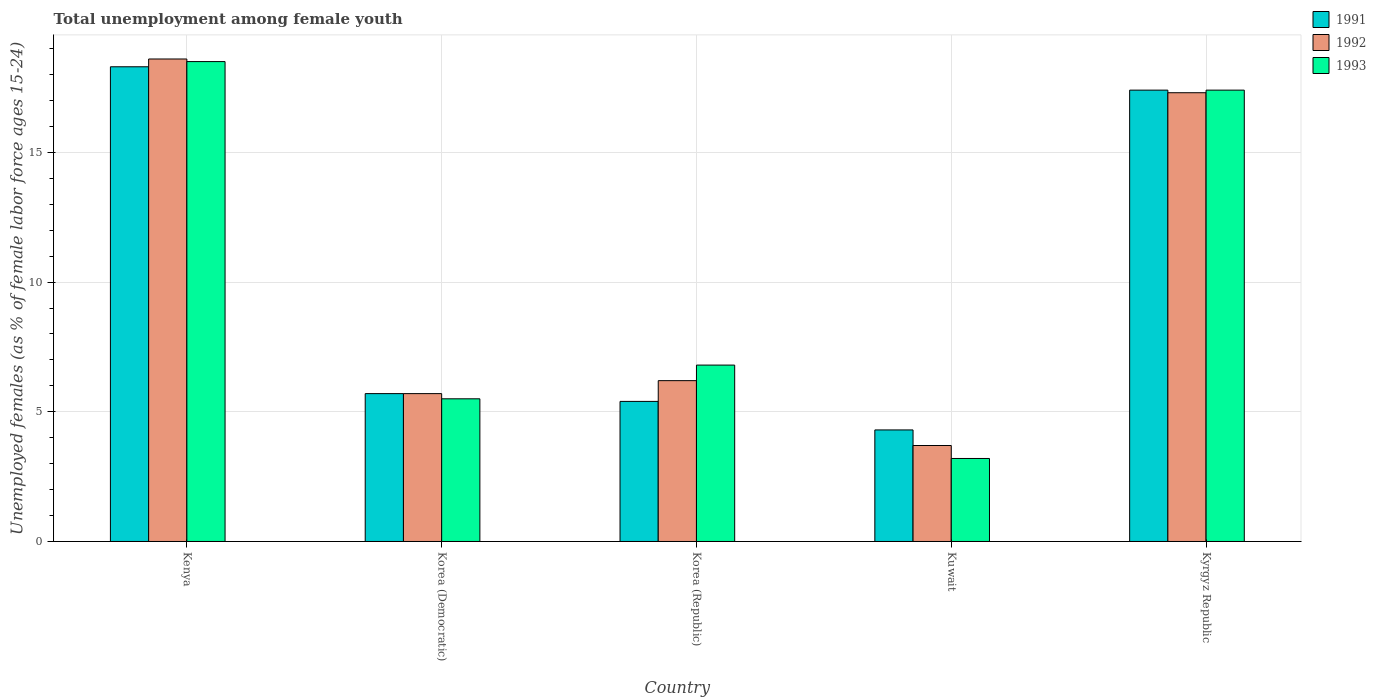How many groups of bars are there?
Provide a short and direct response. 5. Are the number of bars on each tick of the X-axis equal?
Your answer should be very brief. Yes. What is the label of the 2nd group of bars from the left?
Provide a succinct answer. Korea (Democratic). What is the percentage of unemployed females in in 1991 in Kenya?
Your answer should be compact. 18.3. Across all countries, what is the maximum percentage of unemployed females in in 1993?
Provide a short and direct response. 18.5. Across all countries, what is the minimum percentage of unemployed females in in 1993?
Your response must be concise. 3.2. In which country was the percentage of unemployed females in in 1992 maximum?
Offer a very short reply. Kenya. In which country was the percentage of unemployed females in in 1991 minimum?
Offer a terse response. Kuwait. What is the total percentage of unemployed females in in 1992 in the graph?
Your response must be concise. 51.5. What is the difference between the percentage of unemployed females in in 1991 in Korea (Democratic) and that in Kuwait?
Your response must be concise. 1.4. What is the difference between the percentage of unemployed females in in 1991 in Korea (Republic) and the percentage of unemployed females in in 1993 in Kenya?
Ensure brevity in your answer.  -13.1. What is the average percentage of unemployed females in in 1991 per country?
Your answer should be compact. 10.22. What is the difference between the percentage of unemployed females in of/in 1991 and percentage of unemployed females in of/in 1993 in Kyrgyz Republic?
Make the answer very short. 0. In how many countries, is the percentage of unemployed females in in 1992 greater than 11 %?
Make the answer very short. 2. What is the ratio of the percentage of unemployed females in in 1992 in Korea (Democratic) to that in Kuwait?
Make the answer very short. 1.54. Is the percentage of unemployed females in in 1992 in Kuwait less than that in Kyrgyz Republic?
Offer a very short reply. Yes. What is the difference between the highest and the second highest percentage of unemployed females in in 1992?
Ensure brevity in your answer.  -1.3. What is the difference between the highest and the lowest percentage of unemployed females in in 1991?
Make the answer very short. 14. Is it the case that in every country, the sum of the percentage of unemployed females in in 1991 and percentage of unemployed females in in 1992 is greater than the percentage of unemployed females in in 1993?
Give a very brief answer. Yes. How many bars are there?
Ensure brevity in your answer.  15. Are all the bars in the graph horizontal?
Provide a succinct answer. No. Are the values on the major ticks of Y-axis written in scientific E-notation?
Offer a terse response. No. Where does the legend appear in the graph?
Your answer should be compact. Top right. What is the title of the graph?
Provide a short and direct response. Total unemployment among female youth. What is the label or title of the X-axis?
Ensure brevity in your answer.  Country. What is the label or title of the Y-axis?
Offer a terse response. Unemployed females (as % of female labor force ages 15-24). What is the Unemployed females (as % of female labor force ages 15-24) in 1991 in Kenya?
Offer a very short reply. 18.3. What is the Unemployed females (as % of female labor force ages 15-24) in 1992 in Kenya?
Make the answer very short. 18.6. What is the Unemployed females (as % of female labor force ages 15-24) of 1991 in Korea (Democratic)?
Keep it short and to the point. 5.7. What is the Unemployed females (as % of female labor force ages 15-24) of 1992 in Korea (Democratic)?
Ensure brevity in your answer.  5.7. What is the Unemployed females (as % of female labor force ages 15-24) of 1993 in Korea (Democratic)?
Provide a succinct answer. 5.5. What is the Unemployed females (as % of female labor force ages 15-24) in 1991 in Korea (Republic)?
Make the answer very short. 5.4. What is the Unemployed females (as % of female labor force ages 15-24) in 1992 in Korea (Republic)?
Your response must be concise. 6.2. What is the Unemployed females (as % of female labor force ages 15-24) in 1993 in Korea (Republic)?
Offer a terse response. 6.8. What is the Unemployed females (as % of female labor force ages 15-24) in 1991 in Kuwait?
Provide a short and direct response. 4.3. What is the Unemployed females (as % of female labor force ages 15-24) of 1992 in Kuwait?
Offer a very short reply. 3.7. What is the Unemployed females (as % of female labor force ages 15-24) in 1993 in Kuwait?
Your answer should be very brief. 3.2. What is the Unemployed females (as % of female labor force ages 15-24) in 1991 in Kyrgyz Republic?
Offer a very short reply. 17.4. What is the Unemployed females (as % of female labor force ages 15-24) of 1992 in Kyrgyz Republic?
Offer a very short reply. 17.3. What is the Unemployed females (as % of female labor force ages 15-24) in 1993 in Kyrgyz Republic?
Give a very brief answer. 17.4. Across all countries, what is the maximum Unemployed females (as % of female labor force ages 15-24) in 1991?
Your response must be concise. 18.3. Across all countries, what is the maximum Unemployed females (as % of female labor force ages 15-24) in 1992?
Your answer should be compact. 18.6. Across all countries, what is the maximum Unemployed females (as % of female labor force ages 15-24) in 1993?
Offer a very short reply. 18.5. Across all countries, what is the minimum Unemployed females (as % of female labor force ages 15-24) of 1991?
Provide a short and direct response. 4.3. Across all countries, what is the minimum Unemployed females (as % of female labor force ages 15-24) of 1992?
Make the answer very short. 3.7. Across all countries, what is the minimum Unemployed females (as % of female labor force ages 15-24) of 1993?
Keep it short and to the point. 3.2. What is the total Unemployed females (as % of female labor force ages 15-24) in 1991 in the graph?
Offer a very short reply. 51.1. What is the total Unemployed females (as % of female labor force ages 15-24) of 1992 in the graph?
Offer a very short reply. 51.5. What is the total Unemployed females (as % of female labor force ages 15-24) in 1993 in the graph?
Your response must be concise. 51.4. What is the difference between the Unemployed females (as % of female labor force ages 15-24) of 1991 in Kenya and that in Korea (Democratic)?
Your answer should be compact. 12.6. What is the difference between the Unemployed females (as % of female labor force ages 15-24) in 1993 in Kenya and that in Korea (Democratic)?
Provide a succinct answer. 13. What is the difference between the Unemployed females (as % of female labor force ages 15-24) in 1991 in Kenya and that in Korea (Republic)?
Offer a terse response. 12.9. What is the difference between the Unemployed females (as % of female labor force ages 15-24) in 1992 in Kenya and that in Korea (Republic)?
Keep it short and to the point. 12.4. What is the difference between the Unemployed females (as % of female labor force ages 15-24) of 1991 in Kenya and that in Kuwait?
Keep it short and to the point. 14. What is the difference between the Unemployed females (as % of female labor force ages 15-24) in 1992 in Kenya and that in Kuwait?
Provide a succinct answer. 14.9. What is the difference between the Unemployed females (as % of female labor force ages 15-24) of 1991 in Kenya and that in Kyrgyz Republic?
Offer a very short reply. 0.9. What is the difference between the Unemployed females (as % of female labor force ages 15-24) in 1993 in Korea (Democratic) and that in Kuwait?
Provide a succinct answer. 2.3. What is the difference between the Unemployed females (as % of female labor force ages 15-24) of 1991 in Korea (Democratic) and that in Kyrgyz Republic?
Your answer should be very brief. -11.7. What is the difference between the Unemployed females (as % of female labor force ages 15-24) in 1991 in Korea (Republic) and that in Kuwait?
Provide a short and direct response. 1.1. What is the difference between the Unemployed females (as % of female labor force ages 15-24) of 1992 in Korea (Republic) and that in Kuwait?
Your answer should be compact. 2.5. What is the difference between the Unemployed females (as % of female labor force ages 15-24) of 1993 in Korea (Republic) and that in Kuwait?
Your answer should be compact. 3.6. What is the difference between the Unemployed females (as % of female labor force ages 15-24) of 1992 in Korea (Republic) and that in Kyrgyz Republic?
Offer a very short reply. -11.1. What is the difference between the Unemployed females (as % of female labor force ages 15-24) of 1993 in Korea (Republic) and that in Kyrgyz Republic?
Ensure brevity in your answer.  -10.6. What is the difference between the Unemployed females (as % of female labor force ages 15-24) in 1991 in Kuwait and that in Kyrgyz Republic?
Provide a succinct answer. -13.1. What is the difference between the Unemployed females (as % of female labor force ages 15-24) in 1992 in Kuwait and that in Kyrgyz Republic?
Keep it short and to the point. -13.6. What is the difference between the Unemployed females (as % of female labor force ages 15-24) in 1991 in Kenya and the Unemployed females (as % of female labor force ages 15-24) in 1992 in Korea (Democratic)?
Your answer should be very brief. 12.6. What is the difference between the Unemployed females (as % of female labor force ages 15-24) in 1991 in Kenya and the Unemployed females (as % of female labor force ages 15-24) in 1993 in Korea (Republic)?
Offer a very short reply. 11.5. What is the difference between the Unemployed females (as % of female labor force ages 15-24) in 1991 in Kenya and the Unemployed females (as % of female labor force ages 15-24) in 1992 in Kuwait?
Offer a very short reply. 14.6. What is the difference between the Unemployed females (as % of female labor force ages 15-24) in 1991 in Kenya and the Unemployed females (as % of female labor force ages 15-24) in 1993 in Kuwait?
Give a very brief answer. 15.1. What is the difference between the Unemployed females (as % of female labor force ages 15-24) in 1992 in Kenya and the Unemployed females (as % of female labor force ages 15-24) in 1993 in Kuwait?
Your response must be concise. 15.4. What is the difference between the Unemployed females (as % of female labor force ages 15-24) of 1991 in Kenya and the Unemployed females (as % of female labor force ages 15-24) of 1993 in Kyrgyz Republic?
Your response must be concise. 0.9. What is the difference between the Unemployed females (as % of female labor force ages 15-24) of 1992 in Kenya and the Unemployed females (as % of female labor force ages 15-24) of 1993 in Kyrgyz Republic?
Provide a short and direct response. 1.2. What is the difference between the Unemployed females (as % of female labor force ages 15-24) in 1991 in Korea (Democratic) and the Unemployed females (as % of female labor force ages 15-24) in 1992 in Korea (Republic)?
Keep it short and to the point. -0.5. What is the difference between the Unemployed females (as % of female labor force ages 15-24) of 1991 in Korea (Democratic) and the Unemployed females (as % of female labor force ages 15-24) of 1993 in Korea (Republic)?
Offer a very short reply. -1.1. What is the difference between the Unemployed females (as % of female labor force ages 15-24) in 1992 in Korea (Democratic) and the Unemployed females (as % of female labor force ages 15-24) in 1993 in Korea (Republic)?
Make the answer very short. -1.1. What is the difference between the Unemployed females (as % of female labor force ages 15-24) in 1991 in Korea (Democratic) and the Unemployed females (as % of female labor force ages 15-24) in 1993 in Kuwait?
Offer a very short reply. 2.5. What is the difference between the Unemployed females (as % of female labor force ages 15-24) of 1992 in Korea (Democratic) and the Unemployed females (as % of female labor force ages 15-24) of 1993 in Kuwait?
Give a very brief answer. 2.5. What is the difference between the Unemployed females (as % of female labor force ages 15-24) of 1991 in Korea (Democratic) and the Unemployed females (as % of female labor force ages 15-24) of 1993 in Kyrgyz Republic?
Your answer should be compact. -11.7. What is the difference between the Unemployed females (as % of female labor force ages 15-24) in 1992 in Korea (Democratic) and the Unemployed females (as % of female labor force ages 15-24) in 1993 in Kyrgyz Republic?
Provide a short and direct response. -11.7. What is the difference between the Unemployed females (as % of female labor force ages 15-24) of 1991 in Korea (Republic) and the Unemployed females (as % of female labor force ages 15-24) of 1993 in Kuwait?
Offer a very short reply. 2.2. What is the difference between the Unemployed females (as % of female labor force ages 15-24) of 1991 in Korea (Republic) and the Unemployed females (as % of female labor force ages 15-24) of 1992 in Kyrgyz Republic?
Make the answer very short. -11.9. What is the difference between the Unemployed females (as % of female labor force ages 15-24) in 1992 in Korea (Republic) and the Unemployed females (as % of female labor force ages 15-24) in 1993 in Kyrgyz Republic?
Your response must be concise. -11.2. What is the difference between the Unemployed females (as % of female labor force ages 15-24) in 1992 in Kuwait and the Unemployed females (as % of female labor force ages 15-24) in 1993 in Kyrgyz Republic?
Give a very brief answer. -13.7. What is the average Unemployed females (as % of female labor force ages 15-24) of 1991 per country?
Provide a succinct answer. 10.22. What is the average Unemployed females (as % of female labor force ages 15-24) in 1992 per country?
Give a very brief answer. 10.3. What is the average Unemployed females (as % of female labor force ages 15-24) in 1993 per country?
Your answer should be very brief. 10.28. What is the difference between the Unemployed females (as % of female labor force ages 15-24) of 1991 and Unemployed females (as % of female labor force ages 15-24) of 1992 in Kenya?
Offer a terse response. -0.3. What is the difference between the Unemployed females (as % of female labor force ages 15-24) in 1992 and Unemployed females (as % of female labor force ages 15-24) in 1993 in Kenya?
Give a very brief answer. 0.1. What is the difference between the Unemployed females (as % of female labor force ages 15-24) of 1991 and Unemployed females (as % of female labor force ages 15-24) of 1992 in Korea (Republic)?
Give a very brief answer. -0.8. What is the difference between the Unemployed females (as % of female labor force ages 15-24) of 1991 and Unemployed females (as % of female labor force ages 15-24) of 1993 in Korea (Republic)?
Give a very brief answer. -1.4. What is the difference between the Unemployed females (as % of female labor force ages 15-24) of 1991 and Unemployed females (as % of female labor force ages 15-24) of 1992 in Kuwait?
Provide a short and direct response. 0.6. What is the difference between the Unemployed females (as % of female labor force ages 15-24) in 1991 and Unemployed females (as % of female labor force ages 15-24) in 1993 in Kuwait?
Give a very brief answer. 1.1. What is the difference between the Unemployed females (as % of female labor force ages 15-24) in 1991 and Unemployed females (as % of female labor force ages 15-24) in 1992 in Kyrgyz Republic?
Offer a terse response. 0.1. What is the difference between the Unemployed females (as % of female labor force ages 15-24) of 1992 and Unemployed females (as % of female labor force ages 15-24) of 1993 in Kyrgyz Republic?
Give a very brief answer. -0.1. What is the ratio of the Unemployed females (as % of female labor force ages 15-24) of 1991 in Kenya to that in Korea (Democratic)?
Offer a very short reply. 3.21. What is the ratio of the Unemployed females (as % of female labor force ages 15-24) of 1992 in Kenya to that in Korea (Democratic)?
Provide a short and direct response. 3.26. What is the ratio of the Unemployed females (as % of female labor force ages 15-24) of 1993 in Kenya to that in Korea (Democratic)?
Your answer should be compact. 3.36. What is the ratio of the Unemployed females (as % of female labor force ages 15-24) of 1991 in Kenya to that in Korea (Republic)?
Provide a short and direct response. 3.39. What is the ratio of the Unemployed females (as % of female labor force ages 15-24) in 1992 in Kenya to that in Korea (Republic)?
Your answer should be very brief. 3. What is the ratio of the Unemployed females (as % of female labor force ages 15-24) of 1993 in Kenya to that in Korea (Republic)?
Provide a succinct answer. 2.72. What is the ratio of the Unemployed females (as % of female labor force ages 15-24) of 1991 in Kenya to that in Kuwait?
Your response must be concise. 4.26. What is the ratio of the Unemployed females (as % of female labor force ages 15-24) of 1992 in Kenya to that in Kuwait?
Your answer should be very brief. 5.03. What is the ratio of the Unemployed females (as % of female labor force ages 15-24) of 1993 in Kenya to that in Kuwait?
Your response must be concise. 5.78. What is the ratio of the Unemployed females (as % of female labor force ages 15-24) of 1991 in Kenya to that in Kyrgyz Republic?
Offer a very short reply. 1.05. What is the ratio of the Unemployed females (as % of female labor force ages 15-24) of 1992 in Kenya to that in Kyrgyz Republic?
Make the answer very short. 1.08. What is the ratio of the Unemployed females (as % of female labor force ages 15-24) in 1993 in Kenya to that in Kyrgyz Republic?
Your response must be concise. 1.06. What is the ratio of the Unemployed females (as % of female labor force ages 15-24) of 1991 in Korea (Democratic) to that in Korea (Republic)?
Offer a very short reply. 1.06. What is the ratio of the Unemployed females (as % of female labor force ages 15-24) of 1992 in Korea (Democratic) to that in Korea (Republic)?
Offer a terse response. 0.92. What is the ratio of the Unemployed females (as % of female labor force ages 15-24) in 1993 in Korea (Democratic) to that in Korea (Republic)?
Provide a succinct answer. 0.81. What is the ratio of the Unemployed females (as % of female labor force ages 15-24) of 1991 in Korea (Democratic) to that in Kuwait?
Ensure brevity in your answer.  1.33. What is the ratio of the Unemployed females (as % of female labor force ages 15-24) in 1992 in Korea (Democratic) to that in Kuwait?
Your answer should be very brief. 1.54. What is the ratio of the Unemployed females (as % of female labor force ages 15-24) of 1993 in Korea (Democratic) to that in Kuwait?
Provide a succinct answer. 1.72. What is the ratio of the Unemployed females (as % of female labor force ages 15-24) of 1991 in Korea (Democratic) to that in Kyrgyz Republic?
Your answer should be compact. 0.33. What is the ratio of the Unemployed females (as % of female labor force ages 15-24) in 1992 in Korea (Democratic) to that in Kyrgyz Republic?
Offer a very short reply. 0.33. What is the ratio of the Unemployed females (as % of female labor force ages 15-24) in 1993 in Korea (Democratic) to that in Kyrgyz Republic?
Offer a very short reply. 0.32. What is the ratio of the Unemployed females (as % of female labor force ages 15-24) in 1991 in Korea (Republic) to that in Kuwait?
Offer a terse response. 1.26. What is the ratio of the Unemployed females (as % of female labor force ages 15-24) in 1992 in Korea (Republic) to that in Kuwait?
Ensure brevity in your answer.  1.68. What is the ratio of the Unemployed females (as % of female labor force ages 15-24) of 1993 in Korea (Republic) to that in Kuwait?
Give a very brief answer. 2.12. What is the ratio of the Unemployed females (as % of female labor force ages 15-24) of 1991 in Korea (Republic) to that in Kyrgyz Republic?
Keep it short and to the point. 0.31. What is the ratio of the Unemployed females (as % of female labor force ages 15-24) of 1992 in Korea (Republic) to that in Kyrgyz Republic?
Keep it short and to the point. 0.36. What is the ratio of the Unemployed females (as % of female labor force ages 15-24) of 1993 in Korea (Republic) to that in Kyrgyz Republic?
Your answer should be very brief. 0.39. What is the ratio of the Unemployed females (as % of female labor force ages 15-24) of 1991 in Kuwait to that in Kyrgyz Republic?
Offer a terse response. 0.25. What is the ratio of the Unemployed females (as % of female labor force ages 15-24) in 1992 in Kuwait to that in Kyrgyz Republic?
Offer a terse response. 0.21. What is the ratio of the Unemployed females (as % of female labor force ages 15-24) of 1993 in Kuwait to that in Kyrgyz Republic?
Provide a short and direct response. 0.18. What is the difference between the highest and the second highest Unemployed females (as % of female labor force ages 15-24) in 1992?
Make the answer very short. 1.3. What is the difference between the highest and the second highest Unemployed females (as % of female labor force ages 15-24) in 1993?
Make the answer very short. 1.1. What is the difference between the highest and the lowest Unemployed females (as % of female labor force ages 15-24) in 1991?
Make the answer very short. 14. What is the difference between the highest and the lowest Unemployed females (as % of female labor force ages 15-24) in 1992?
Your answer should be compact. 14.9. 